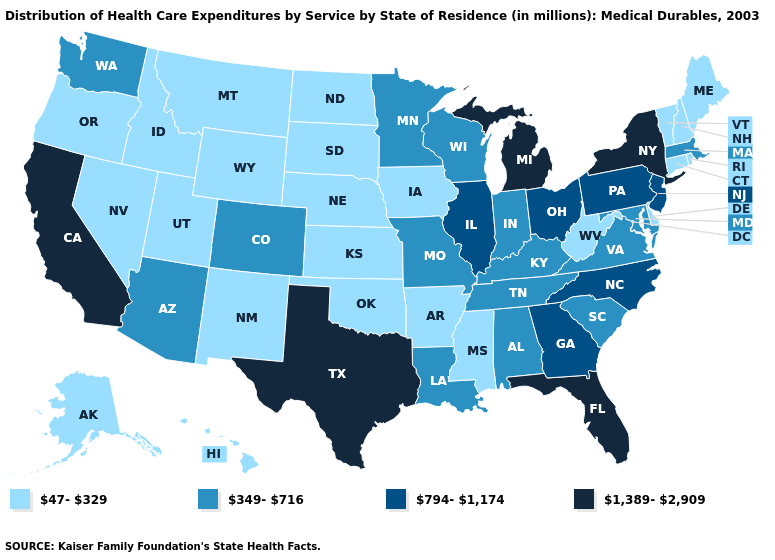Does the first symbol in the legend represent the smallest category?
Quick response, please. Yes. Does Washington have the same value as Virginia?
Write a very short answer. Yes. Does Vermont have the lowest value in the USA?
Short answer required. Yes. What is the lowest value in states that border New Mexico?
Be succinct. 47-329. Among the states that border Oregon , which have the highest value?
Short answer required. California. Does Louisiana have a higher value than Florida?
Be succinct. No. What is the highest value in the USA?
Be succinct. 1,389-2,909. Name the states that have a value in the range 794-1,174?
Concise answer only. Georgia, Illinois, New Jersey, North Carolina, Ohio, Pennsylvania. What is the lowest value in the West?
Quick response, please. 47-329. What is the value of Vermont?
Write a very short answer. 47-329. What is the highest value in states that border Oregon?
Be succinct. 1,389-2,909. Name the states that have a value in the range 47-329?
Quick response, please. Alaska, Arkansas, Connecticut, Delaware, Hawaii, Idaho, Iowa, Kansas, Maine, Mississippi, Montana, Nebraska, Nevada, New Hampshire, New Mexico, North Dakota, Oklahoma, Oregon, Rhode Island, South Dakota, Utah, Vermont, West Virginia, Wyoming. What is the value of West Virginia?
Short answer required. 47-329. Does the map have missing data?
Quick response, please. No. What is the lowest value in the USA?
Give a very brief answer. 47-329. 